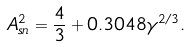<formula> <loc_0><loc_0><loc_500><loc_500>A _ { s n } ^ { 2 } = \frac { 4 } { 3 } + 0 . 3 0 4 8 \gamma ^ { 2 / 3 } .</formula> 